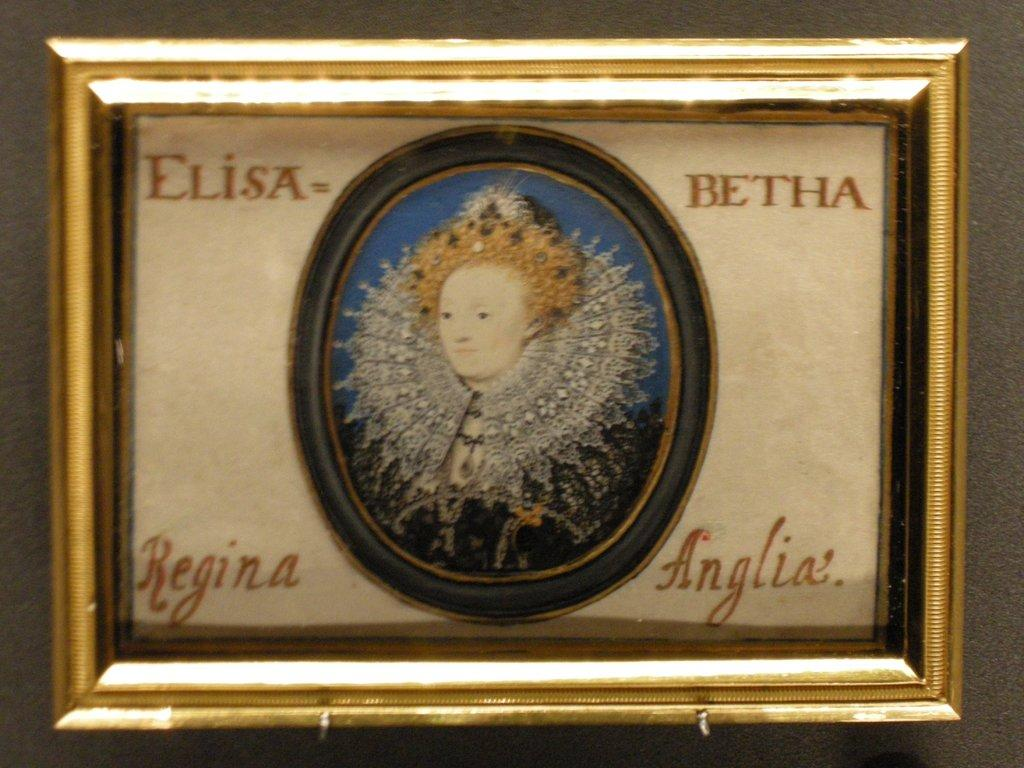Provide a one-sentence caption for the provided image. A gold frame with a woman pictured in the center and the words Elisa Betha Regina Anglia written around the photo. 